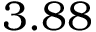Convert formula to latex. <formula><loc_0><loc_0><loc_500><loc_500>3 . 8 8</formula> 